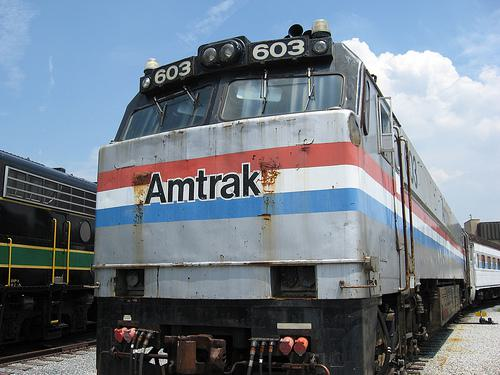How many unicorns are there in the image? 0 